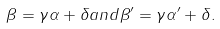<formula> <loc_0><loc_0><loc_500><loc_500>\beta = \gamma \alpha + \delta a n d \beta ^ { \prime } = \gamma \alpha ^ { \prime } + \delta .</formula> 